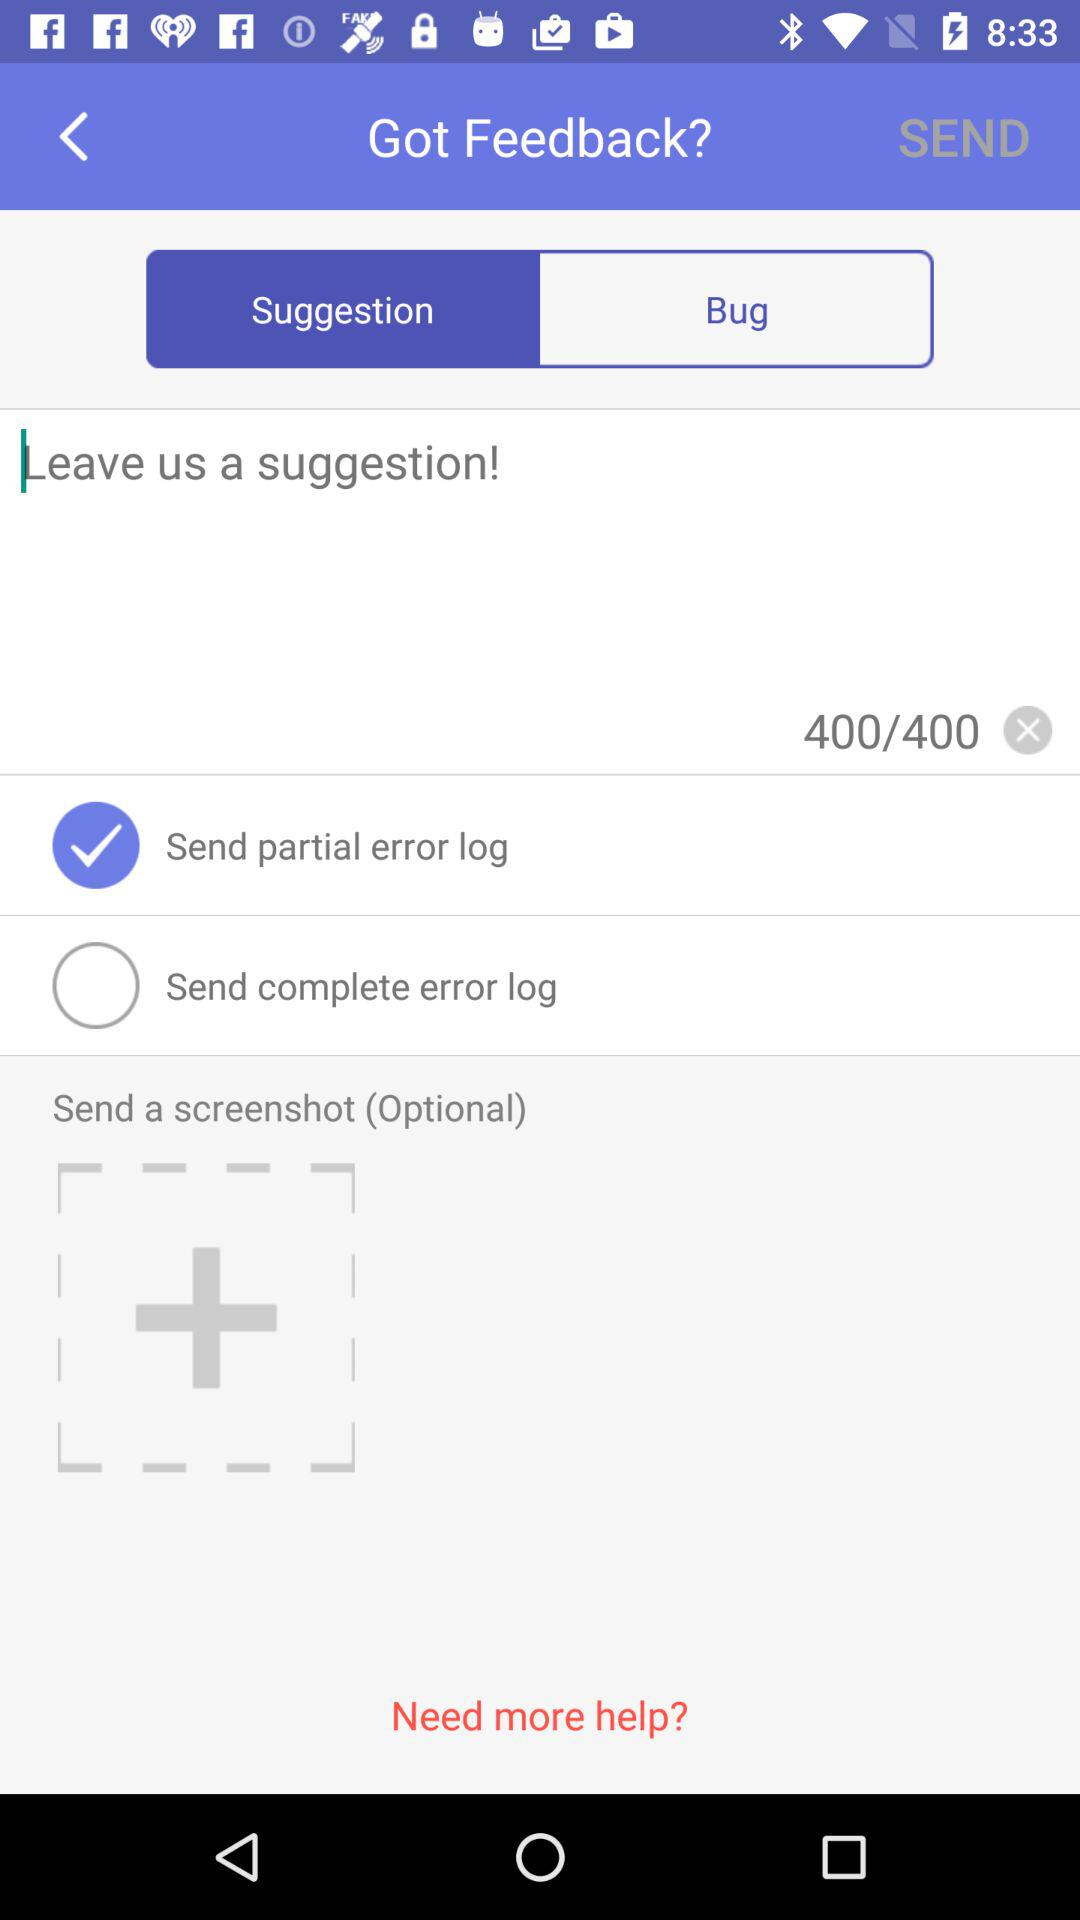Which option is selected? The selected options are "Suggestion" and "Send partial error log". 